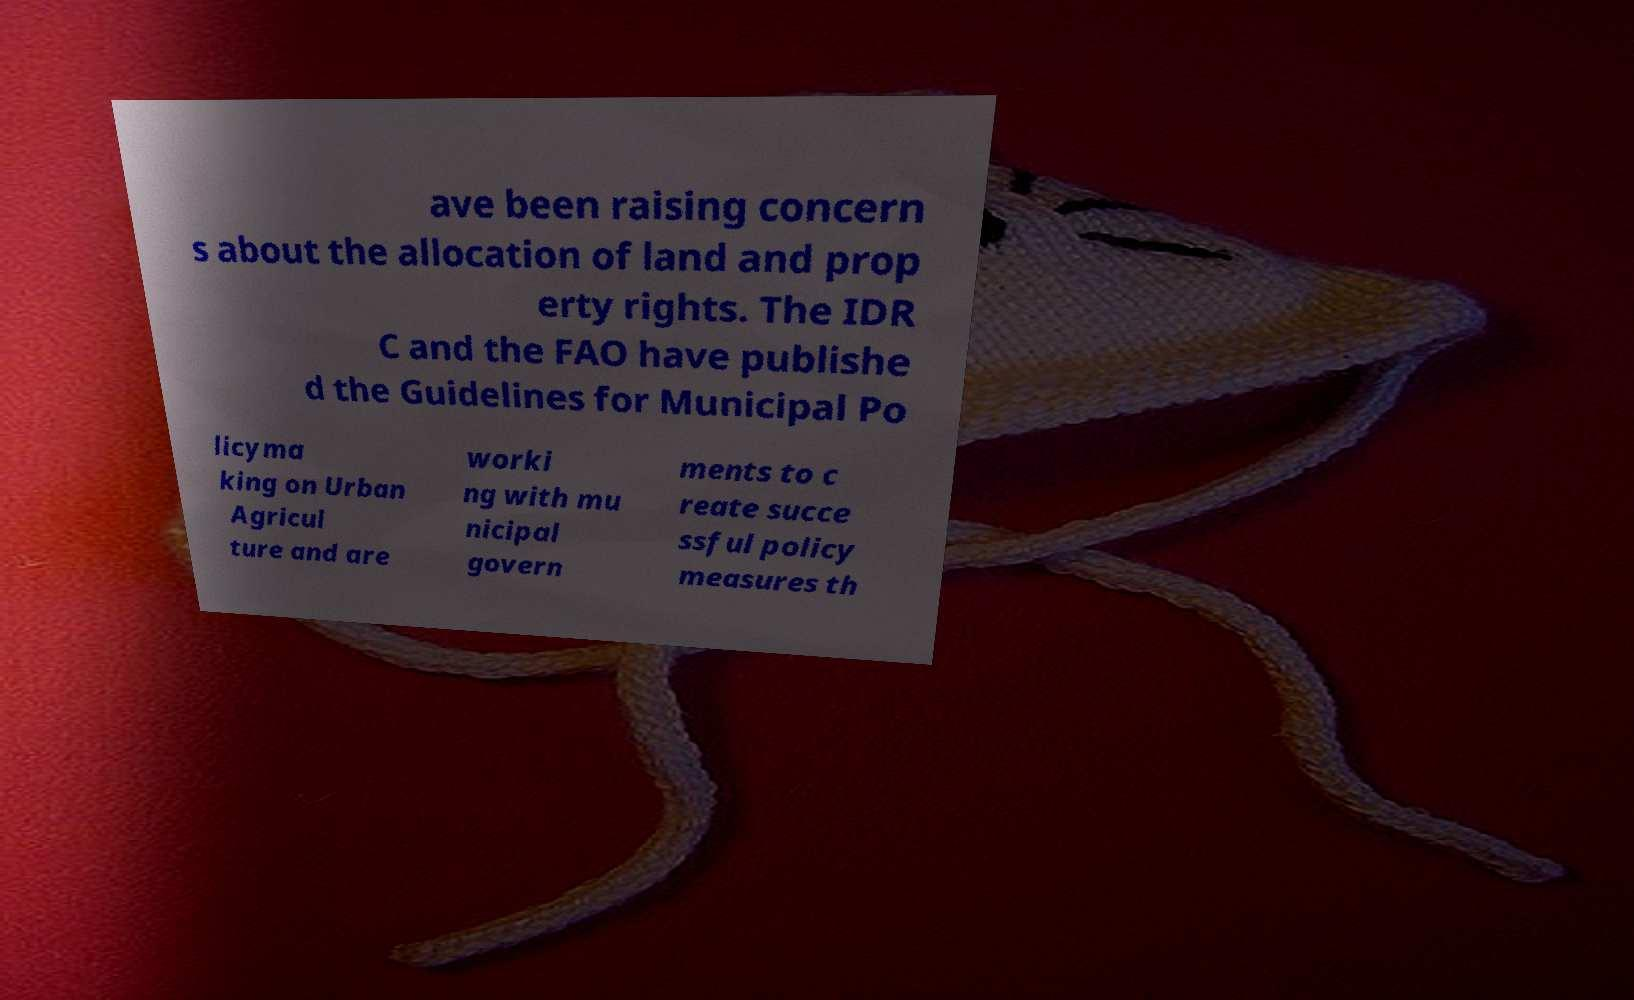For documentation purposes, I need the text within this image transcribed. Could you provide that? ave been raising concern s about the allocation of land and prop erty rights. The IDR C and the FAO have publishe d the Guidelines for Municipal Po licyma king on Urban Agricul ture and are worki ng with mu nicipal govern ments to c reate succe ssful policy measures th 